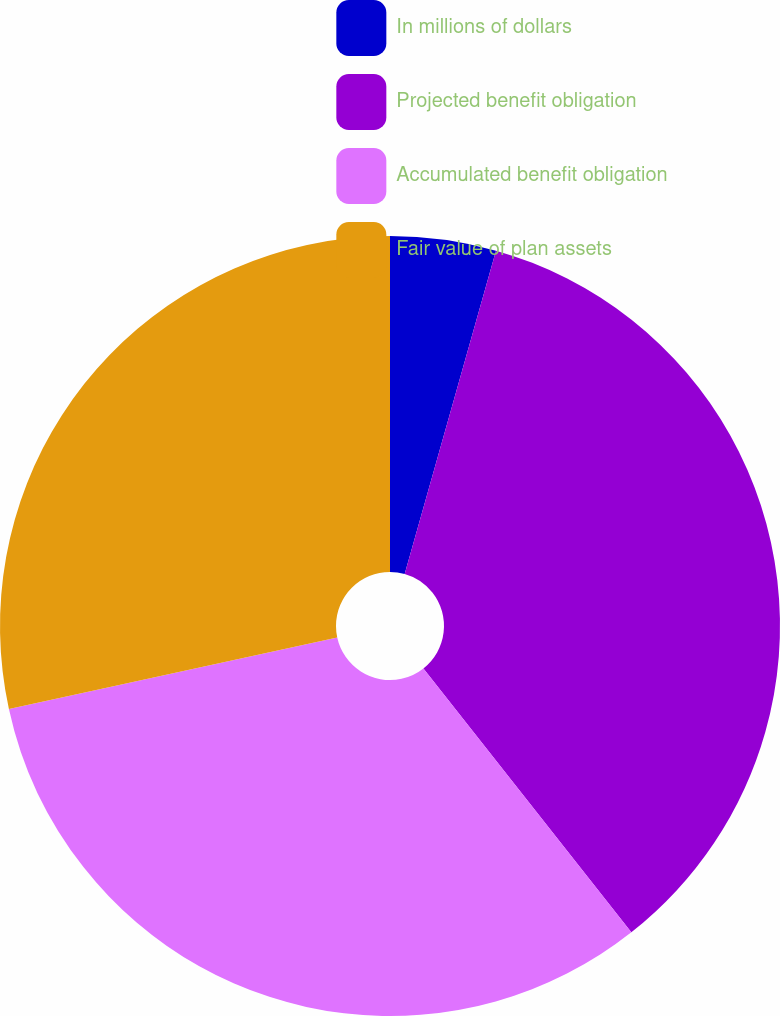<chart> <loc_0><loc_0><loc_500><loc_500><pie_chart><fcel>In millions of dollars<fcel>Projected benefit obligation<fcel>Accumulated benefit obligation<fcel>Fair value of plan assets<nl><fcel>4.38%<fcel>35.0%<fcel>32.21%<fcel>28.41%<nl></chart> 